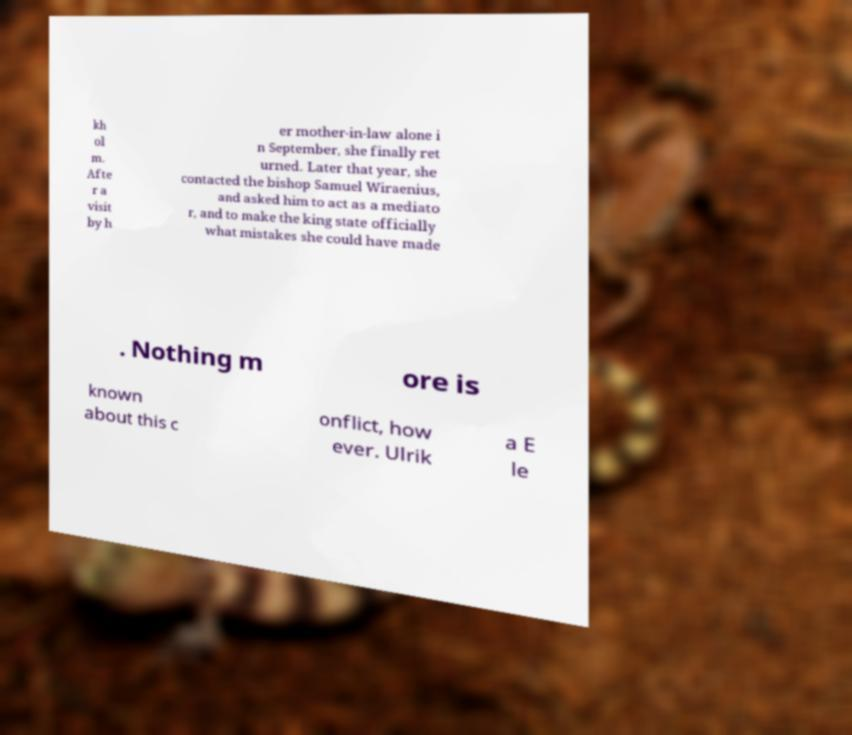Could you extract and type out the text from this image? kh ol m. Afte r a visit by h er mother-in-law alone i n September, she finally ret urned. Later that year, she contacted the bishop Samuel Wiraenius, and asked him to act as a mediato r, and to make the king state officially what mistakes she could have made . Nothing m ore is known about this c onflict, how ever. Ulrik a E le 